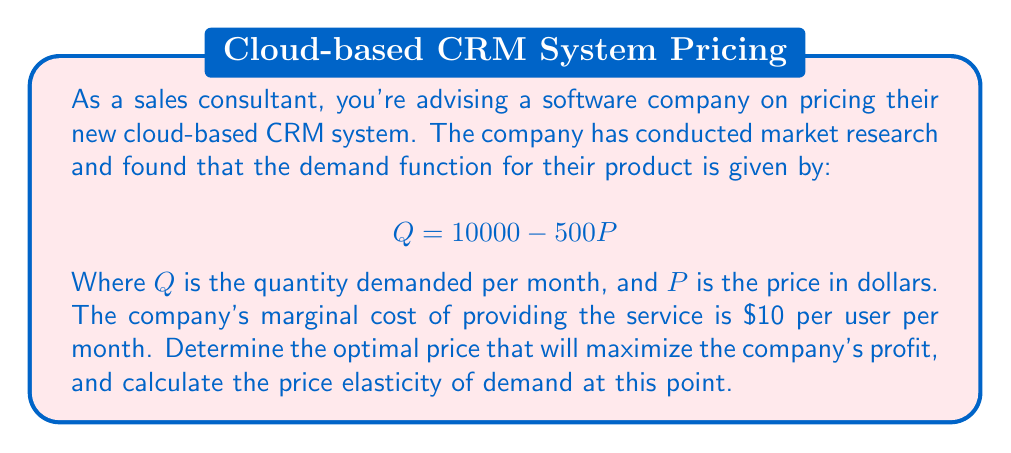Solve this math problem. To solve this problem, we'll follow these steps:

1) First, let's find the inverse demand function:
   $$P = 20 - \frac{Q}{500}$$

2) The total revenue (TR) function is:
   $$TR = P \cdot Q = (20 - \frac{Q}{500}) \cdot Q = 20Q - \frac{Q^2}{500}$$

3) The marginal revenue (MR) function is the derivative of TR with respect to Q:
   $$MR = \frac{d(TR)}{dQ} = 20 - \frac{Q}{250}$$

4) For profit maximization, we set MR equal to MC:
   $$20 - \frac{Q}{250} = 10$$
   $$10 = \frac{Q}{250}$$
   $$Q = 2500$$

5) Now we can find the optimal price by substituting Q back into the inverse demand function:
   $$P = 20 - \frac{2500}{500} = 20 - 5 = 15$$

6) To calculate the price elasticity of demand at this point, we use the formula:
   $$E_d = -\frac{dQ}{dP} \cdot \frac{P}{Q}$$

   From the original demand function, we know that $\frac{dQ}{dP} = -500$

   Substituting our values:
   $$E_d = -(-500) \cdot \frac{15}{2500} = 3$$

Thus, at the optimal price, the demand is elastic with a price elasticity of 3, meaning a 1% increase in price would lead to a 3% decrease in quantity demanded.
Answer: The optimal price is $15 per user per month, and the price elasticity of demand at this point is 3. 